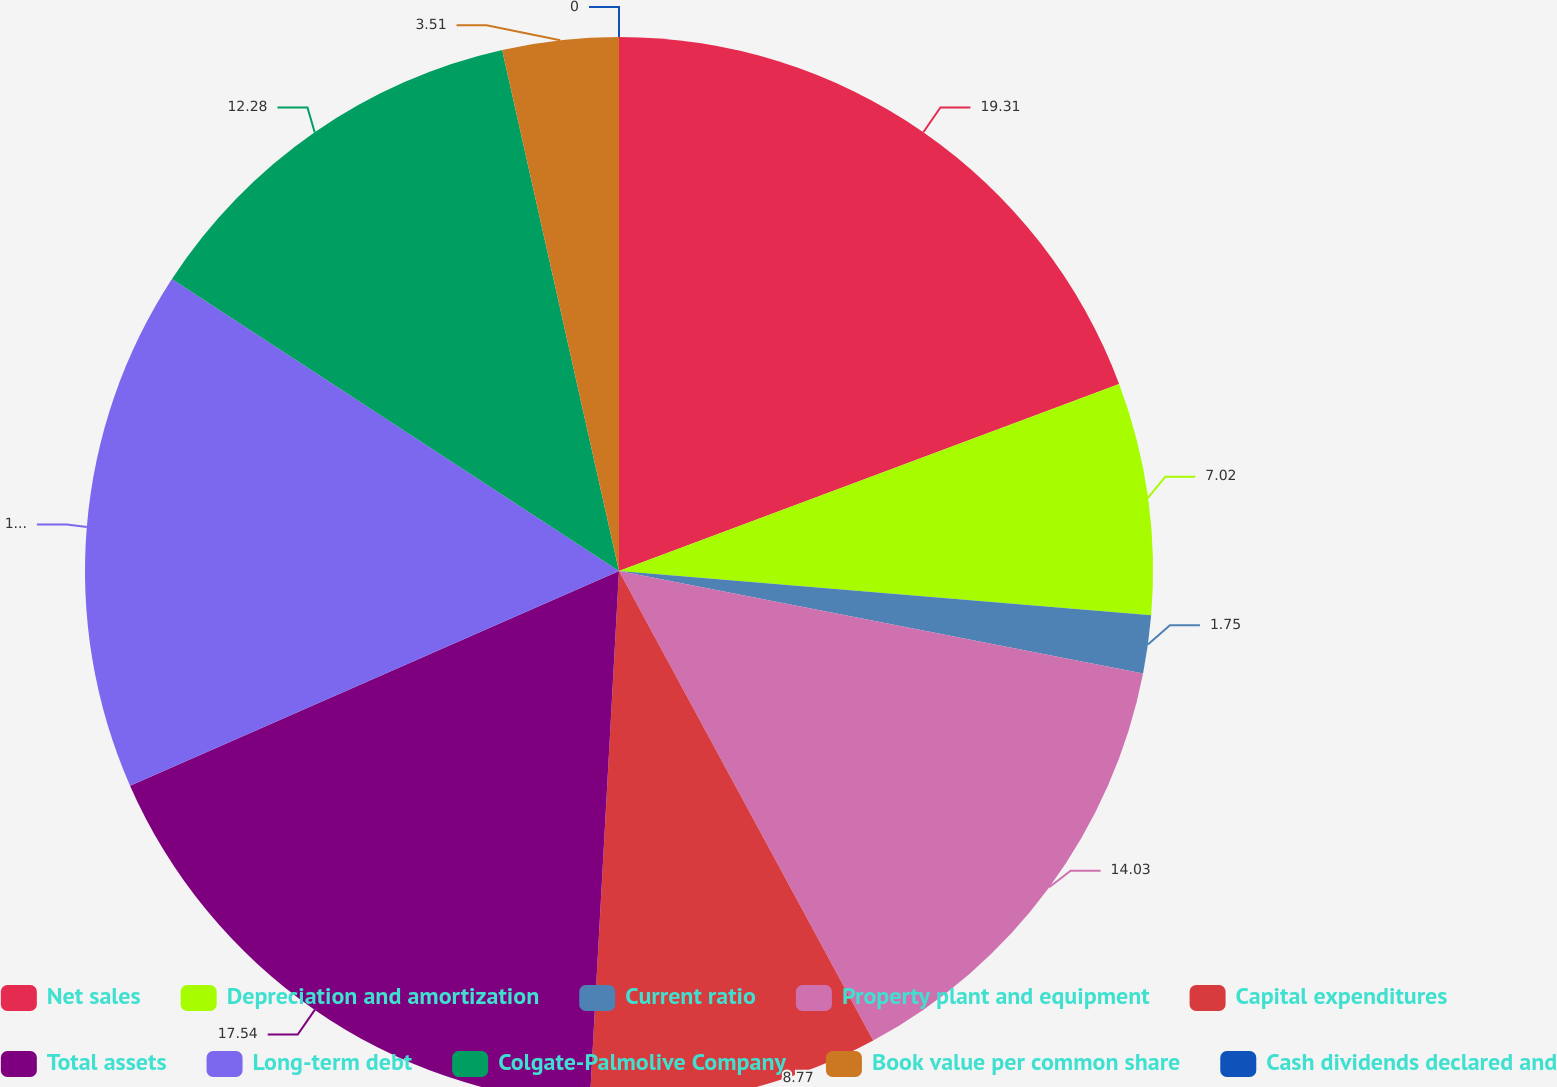Convert chart. <chart><loc_0><loc_0><loc_500><loc_500><pie_chart><fcel>Net sales<fcel>Depreciation and amortization<fcel>Current ratio<fcel>Property plant and equipment<fcel>Capital expenditures<fcel>Total assets<fcel>Long-term debt<fcel>Colgate-Palmolive Company<fcel>Book value per common share<fcel>Cash dividends declared and<nl><fcel>19.3%<fcel>7.02%<fcel>1.75%<fcel>14.03%<fcel>8.77%<fcel>17.54%<fcel>15.79%<fcel>12.28%<fcel>3.51%<fcel>0.0%<nl></chart> 